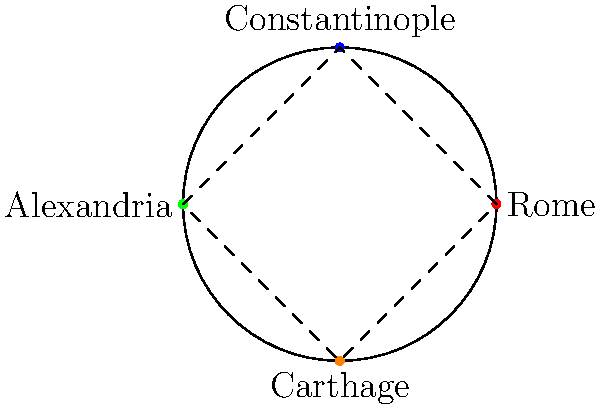In a polar coordinate system representing major trade routes between historical empires, Rome is located at $(r, 0°)$, Constantinople at $(r, 90°)$, Alexandria at $(r, 180°)$, and Carthage at $(r, 270°)$, where $r$ is a constant radius. If a ship travels from Rome to Alexandria along the shortest path on this system, what is the angular distance it covers? To solve this problem, we need to follow these steps:

1) In a polar coordinate system, the angular coordinate represents the angle from the positive x-axis (usually measured counterclockwise).

2) Rome is located at $(r, 0°)$ and Alexandria at $(r, 180°)$.

3) The shortest path between two points on a circle is the arc of the circle that connects them.

4) To find the angular distance, we need to calculate the difference between the angular coordinates of Alexandria and Rome:

   $180° - 0° = 180°$

5) However, we need to consider that the ship could travel in either direction (clockwise or counterclockwise). The shortest path would be the smaller of the two possible angles.

6) In this case, $180°$ is already the smaller angle (as opposed to $360° - 180° = 180°$).

Therefore, the angular distance covered by the ship traveling from Rome to Alexandria along the shortest path is $180°$.
Answer: $180°$ 